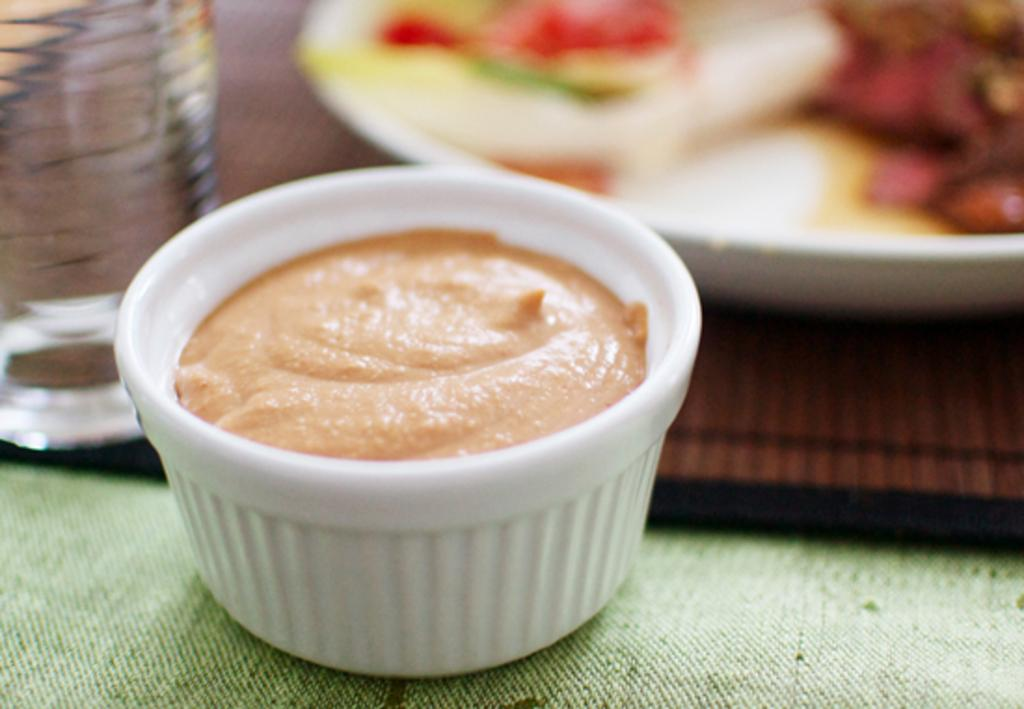What is on the cloth in the image? The cloth has a bowl on it. What is inside the bowl on the cloth? The bowl contains food. What other items are present in the image besides the cloth and bowl? There is a bottle and a plate in the image. What is on the plate in the image? The plate has food on it. Where are the plate and the bottle located in the image? The plate and the bottle are on a table. Where is the cannon located in the image? There is no cannon present in the image. What type of key is used to open the bottle in the image? There is no key involved in opening the bottle in the image; it is likely a twist-off cap or requires a bottle opener. 